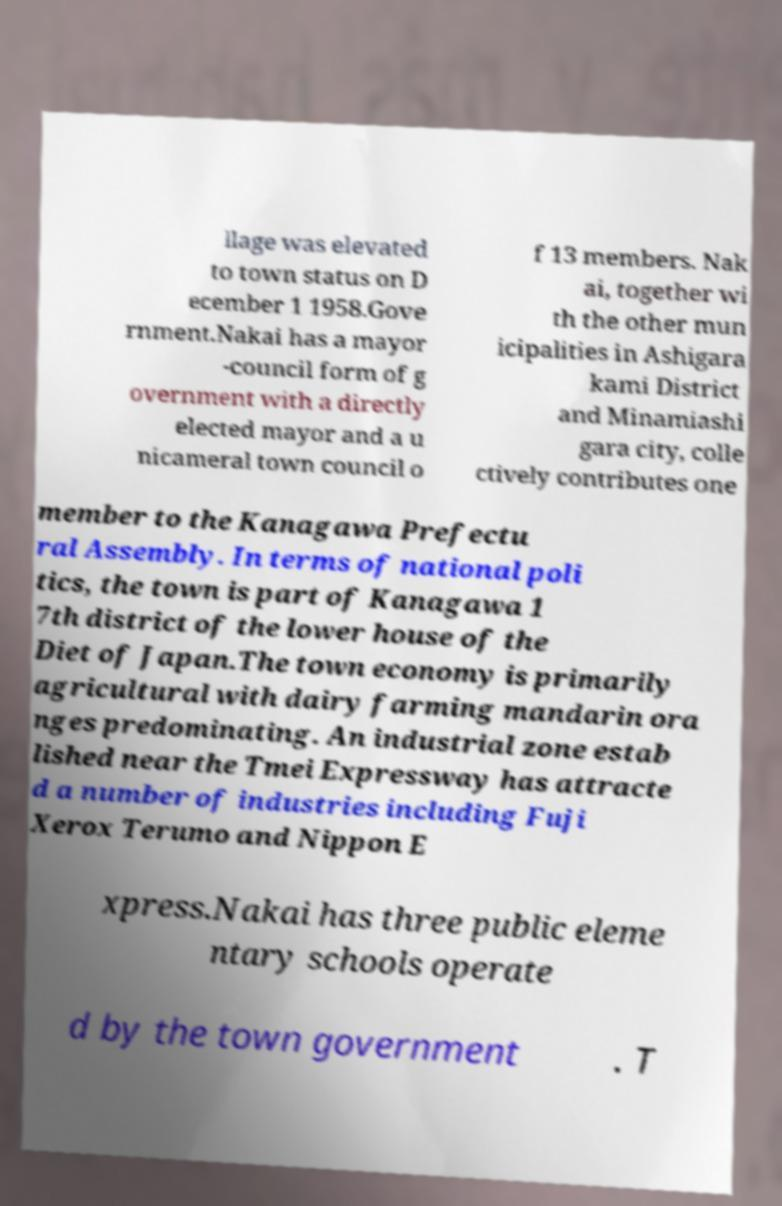Could you assist in decoding the text presented in this image and type it out clearly? llage was elevated to town status on D ecember 1 1958.Gove rnment.Nakai has a mayor -council form of g overnment with a directly elected mayor and a u nicameral town council o f 13 members. Nak ai, together wi th the other mun icipalities in Ashigara kami District and Minamiashi gara city, colle ctively contributes one member to the Kanagawa Prefectu ral Assembly. In terms of national poli tics, the town is part of Kanagawa 1 7th district of the lower house of the Diet of Japan.The town economy is primarily agricultural with dairy farming mandarin ora nges predominating. An industrial zone estab lished near the Tmei Expressway has attracte d a number of industries including Fuji Xerox Terumo and Nippon E xpress.Nakai has three public eleme ntary schools operate d by the town government . T 